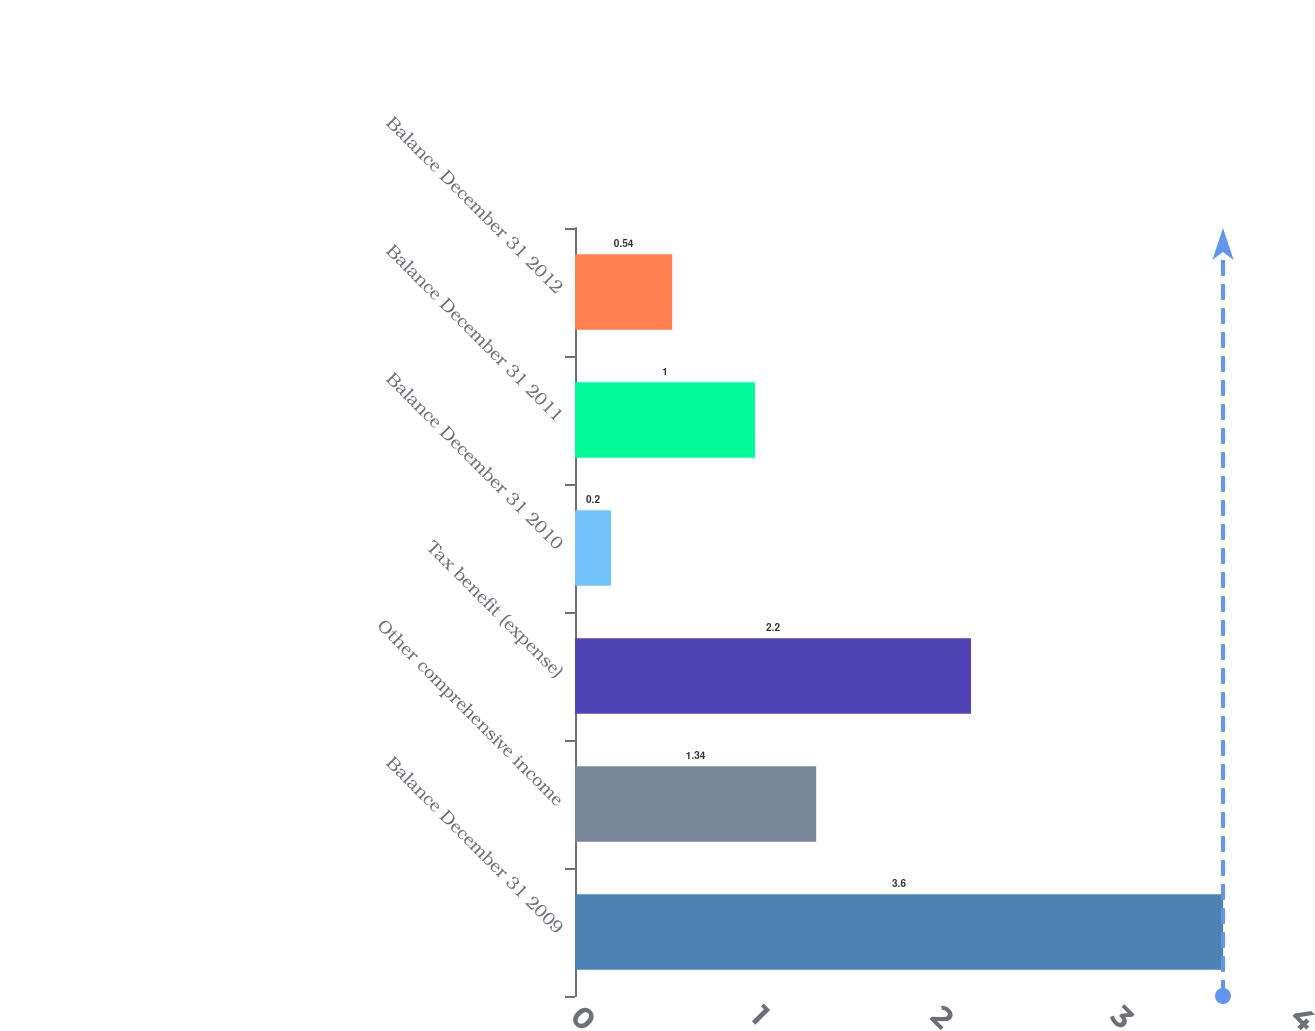<chart> <loc_0><loc_0><loc_500><loc_500><bar_chart><fcel>Balance December 31 2009<fcel>Other comprehensive income<fcel>Tax benefit (expense)<fcel>Balance December 31 2010<fcel>Balance December 31 2011<fcel>Balance December 31 2012<nl><fcel>3.6<fcel>1.34<fcel>2.2<fcel>0.2<fcel>1<fcel>0.54<nl></chart> 